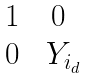<formula> <loc_0><loc_0><loc_500><loc_500>\begin{matrix} 1 & 0 \\ 0 & \ Y _ { i _ { d } } \end{matrix}</formula> 